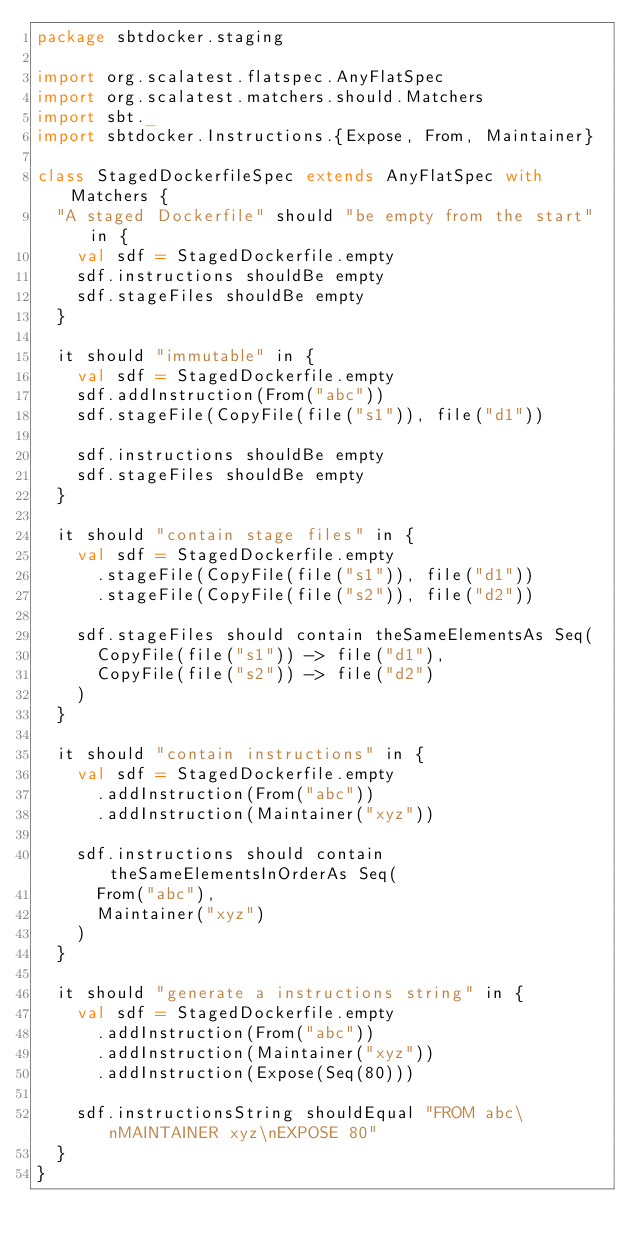Convert code to text. <code><loc_0><loc_0><loc_500><loc_500><_Scala_>package sbtdocker.staging

import org.scalatest.flatspec.AnyFlatSpec
import org.scalatest.matchers.should.Matchers
import sbt._
import sbtdocker.Instructions.{Expose, From, Maintainer}

class StagedDockerfileSpec extends AnyFlatSpec with Matchers {
  "A staged Dockerfile" should "be empty from the start" in {
    val sdf = StagedDockerfile.empty
    sdf.instructions shouldBe empty
    sdf.stageFiles shouldBe empty
  }

  it should "immutable" in {
    val sdf = StagedDockerfile.empty
    sdf.addInstruction(From("abc"))
    sdf.stageFile(CopyFile(file("s1")), file("d1"))

    sdf.instructions shouldBe empty
    sdf.stageFiles shouldBe empty
  }

  it should "contain stage files" in {
    val sdf = StagedDockerfile.empty
      .stageFile(CopyFile(file("s1")), file("d1"))
      .stageFile(CopyFile(file("s2")), file("d2"))

    sdf.stageFiles should contain theSameElementsAs Seq(
      CopyFile(file("s1")) -> file("d1"),
      CopyFile(file("s2")) -> file("d2")
    )
  }

  it should "contain instructions" in {
    val sdf = StagedDockerfile.empty
      .addInstruction(From("abc"))
      .addInstruction(Maintainer("xyz"))

    sdf.instructions should contain theSameElementsInOrderAs Seq(
      From("abc"),
      Maintainer("xyz")
    )
  }

  it should "generate a instructions string" in {
    val sdf = StagedDockerfile.empty
      .addInstruction(From("abc"))
      .addInstruction(Maintainer("xyz"))
      .addInstruction(Expose(Seq(80)))

    sdf.instructionsString shouldEqual "FROM abc\nMAINTAINER xyz\nEXPOSE 80"
  }
}
</code> 